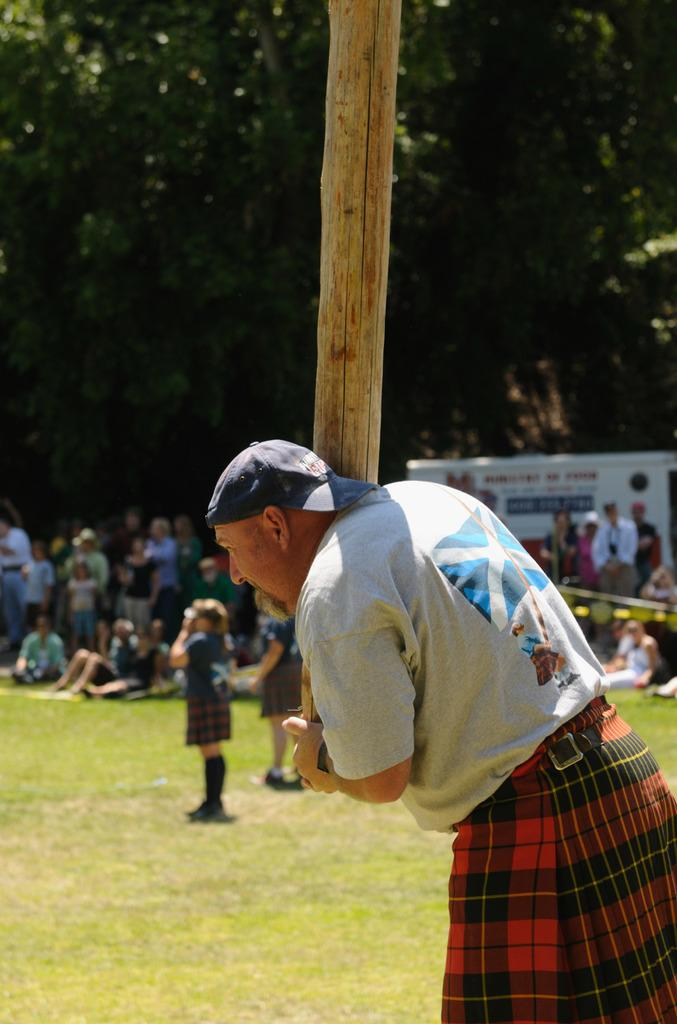What is the man in the image doing? The man is standing in the image. What is the man holding in the image? The man is holding a wooden object. What type of natural environment is visible in the image? There is grass visible in the image. What can be seen in the background of the image? There are people, a vehicle, and trees in the background of the image. What type of insect is the man thinking about in the image? There is no indication in the image that the man is thinking about any insects. 